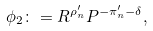<formula> <loc_0><loc_0><loc_500><loc_500>\phi _ { 2 } \colon = R ^ { \rho _ { n } ^ { \prime } } P ^ { - \pi _ { n } ^ { \prime } - \delta } ,</formula> 